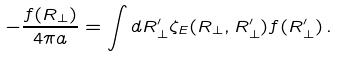<formula> <loc_0><loc_0><loc_500><loc_500>- \frac { f ( { R } _ { \perp } ) } { 4 \pi a } = \int d { R } _ { \perp } ^ { \prime } \zeta _ { E } ( { R } _ { \perp } , { R } _ { \perp } ^ { \prime } ) f ( { R } _ { \perp } ^ { \prime } ) \, .</formula> 